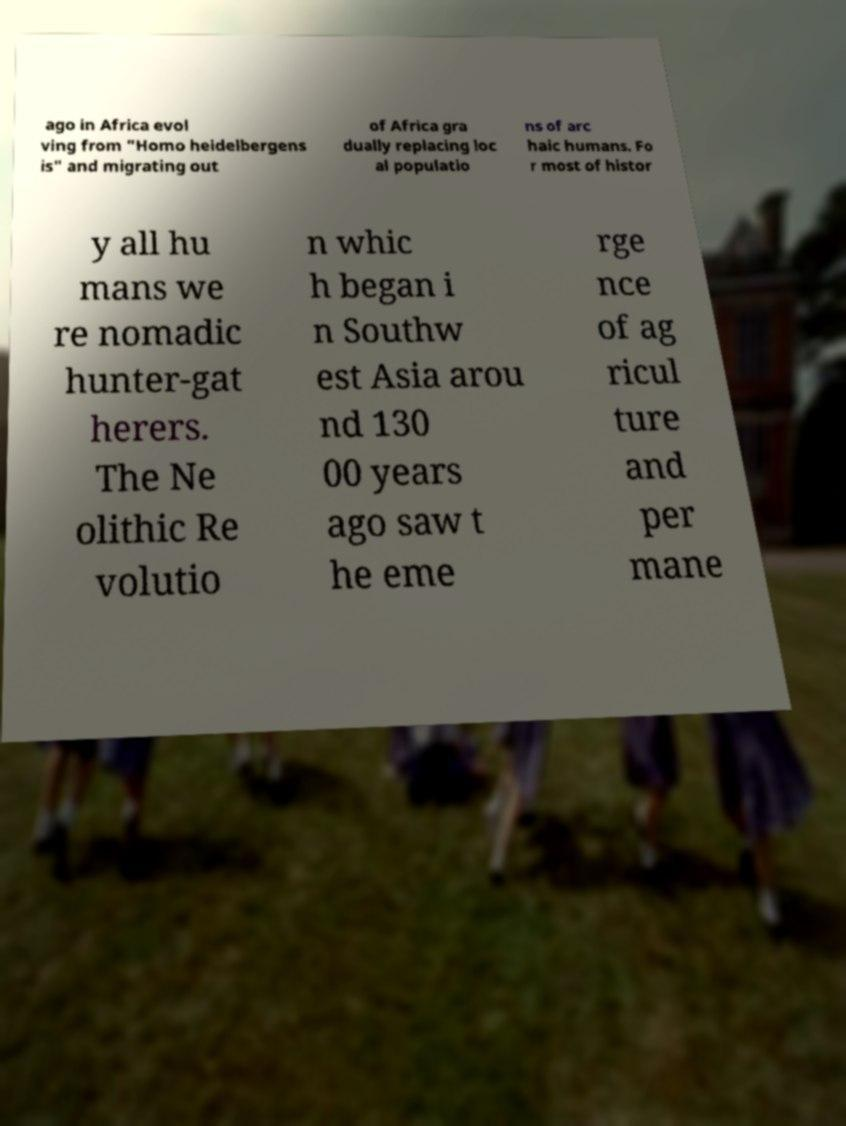Can you accurately transcribe the text from the provided image for me? ago in Africa evol ving from "Homo heidelbergens is" and migrating out of Africa gra dually replacing loc al populatio ns of arc haic humans. Fo r most of histor y all hu mans we re nomadic hunter-gat herers. The Ne olithic Re volutio n whic h began i n Southw est Asia arou nd 130 00 years ago saw t he eme rge nce of ag ricul ture and per mane 